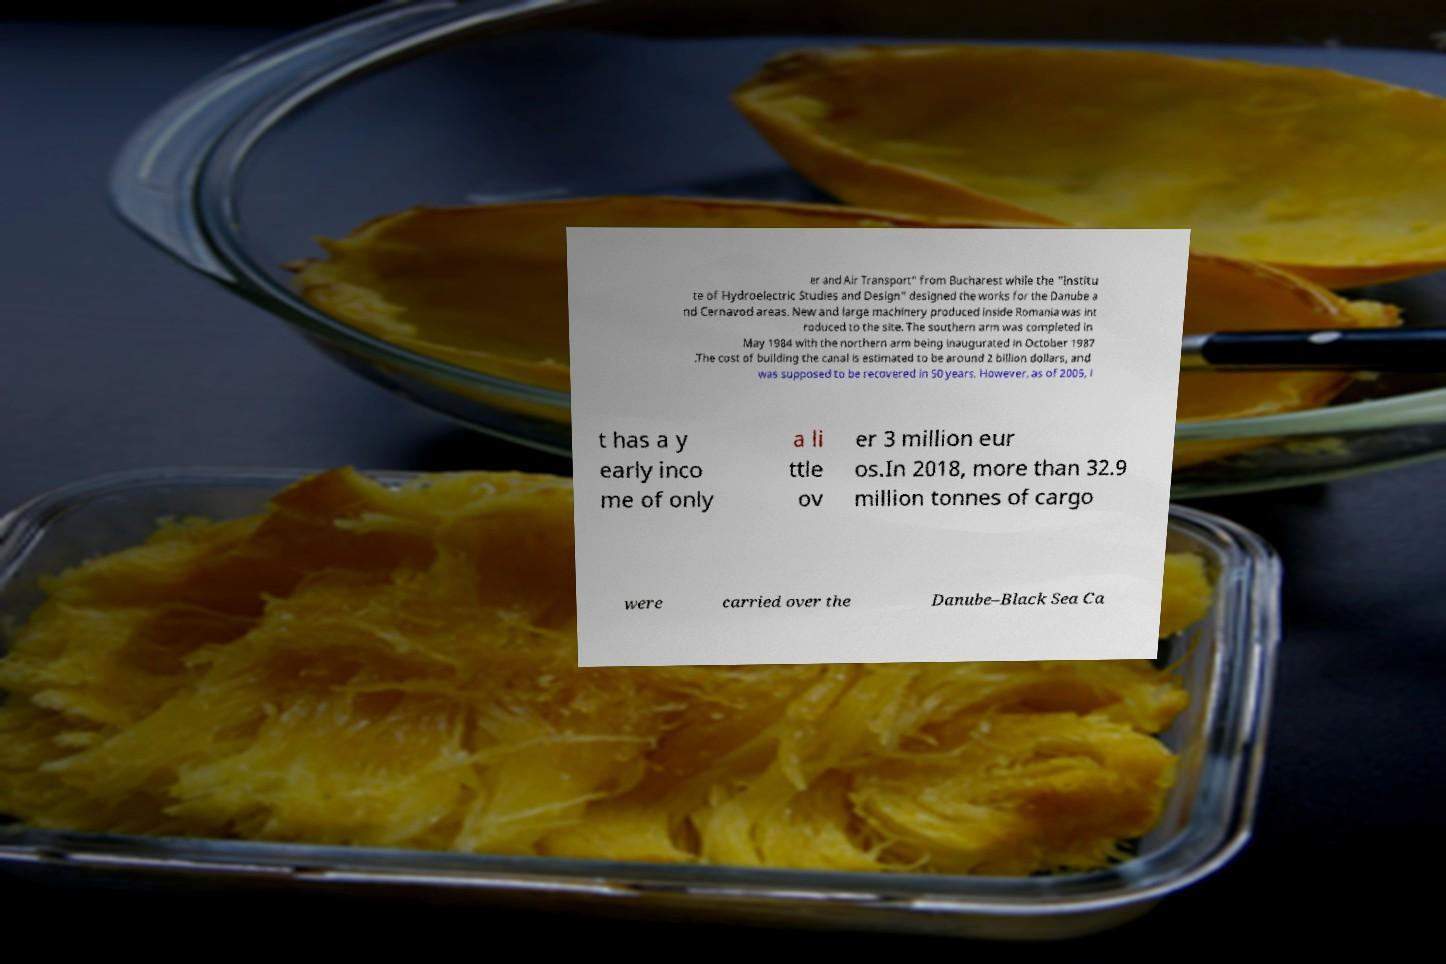Could you assist in decoding the text presented in this image and type it out clearly? er and Air Transport" from Bucharest while the "Institu te of Hydroelectric Studies and Design" designed the works for the Danube a nd Cernavod areas. New and large machinery produced inside Romania was int roduced to the site. The southern arm was completed in May 1984 with the northern arm being inaugurated in October 1987 .The cost of building the canal is estimated to be around 2 billion dollars, and was supposed to be recovered in 50 years. However, as of 2005, i t has a y early inco me of only a li ttle ov er 3 million eur os.In 2018, more than 32.9 million tonnes of cargo were carried over the Danube–Black Sea Ca 